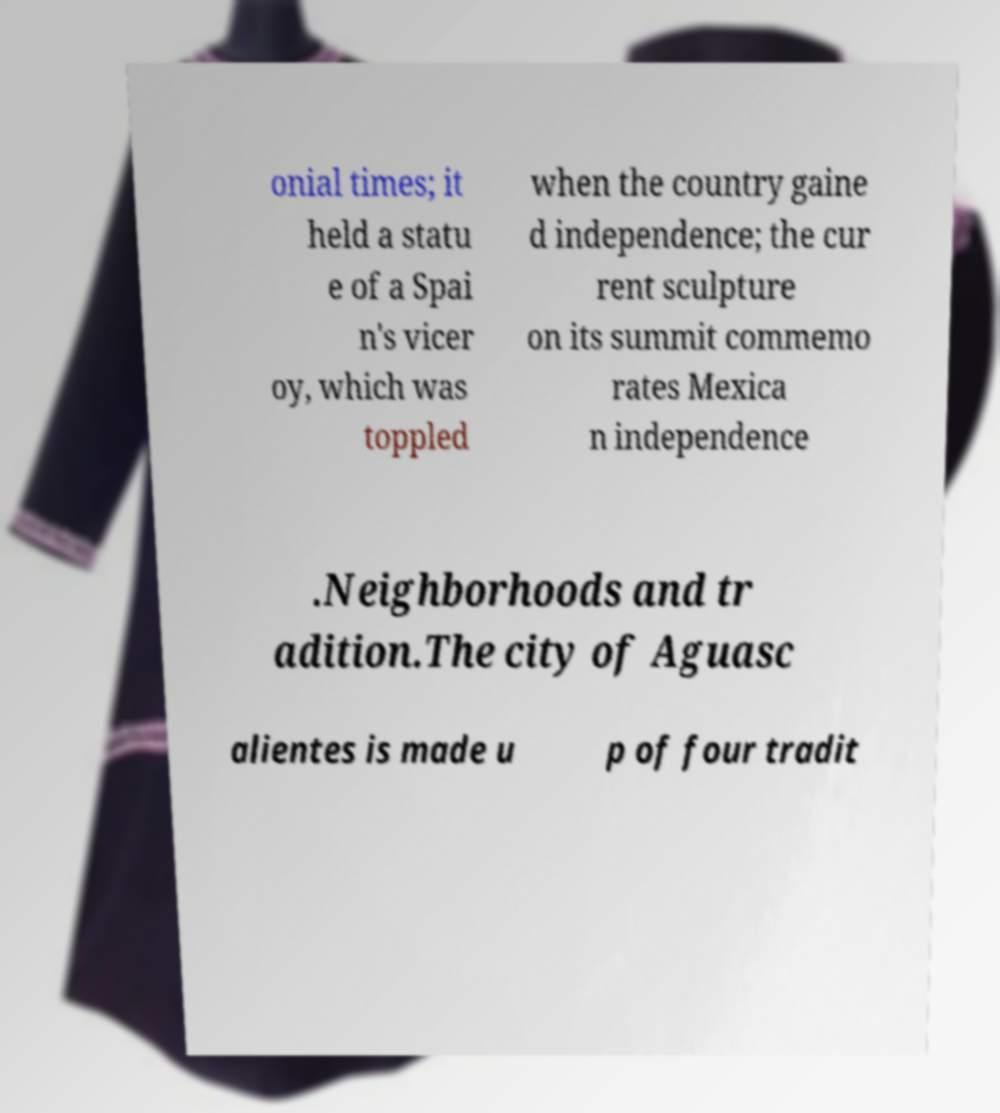There's text embedded in this image that I need extracted. Can you transcribe it verbatim? onial times; it held a statu e of a Spai n's vicer oy, which was toppled when the country gaine d independence; the cur rent sculpture on its summit commemo rates Mexica n independence .Neighborhoods and tr adition.The city of Aguasc alientes is made u p of four tradit 